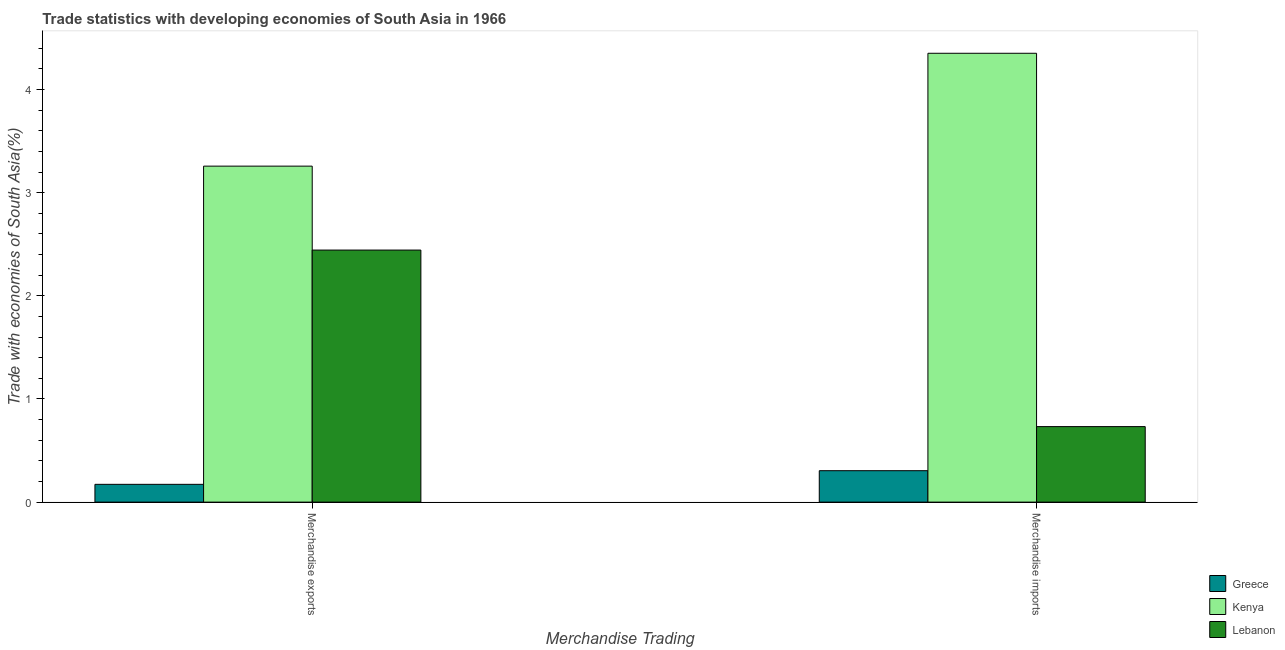How many groups of bars are there?
Your answer should be compact. 2. Are the number of bars per tick equal to the number of legend labels?
Your response must be concise. Yes. How many bars are there on the 2nd tick from the left?
Your response must be concise. 3. How many bars are there on the 2nd tick from the right?
Your answer should be very brief. 3. What is the label of the 2nd group of bars from the left?
Ensure brevity in your answer.  Merchandise imports. What is the merchandise imports in Greece?
Your response must be concise. 0.3. Across all countries, what is the maximum merchandise exports?
Provide a short and direct response. 3.26. Across all countries, what is the minimum merchandise imports?
Ensure brevity in your answer.  0.3. In which country was the merchandise exports maximum?
Offer a very short reply. Kenya. What is the total merchandise exports in the graph?
Your response must be concise. 5.87. What is the difference between the merchandise imports in Kenya and that in Greece?
Your answer should be compact. 4.05. What is the difference between the merchandise imports in Kenya and the merchandise exports in Lebanon?
Give a very brief answer. 1.91. What is the average merchandise imports per country?
Offer a very short reply. 1.8. What is the difference between the merchandise imports and merchandise exports in Lebanon?
Your answer should be compact. -1.71. What is the ratio of the merchandise exports in Greece to that in Lebanon?
Ensure brevity in your answer.  0.07. In how many countries, is the merchandise exports greater than the average merchandise exports taken over all countries?
Your response must be concise. 2. What does the 2nd bar from the left in Merchandise exports represents?
Keep it short and to the point. Kenya. What does the 1st bar from the right in Merchandise exports represents?
Offer a terse response. Lebanon. How many bars are there?
Your answer should be compact. 6. What is the difference between two consecutive major ticks on the Y-axis?
Ensure brevity in your answer.  1. Are the values on the major ticks of Y-axis written in scientific E-notation?
Give a very brief answer. No. Does the graph contain any zero values?
Provide a succinct answer. No. Does the graph contain grids?
Give a very brief answer. No. How are the legend labels stacked?
Keep it short and to the point. Vertical. What is the title of the graph?
Keep it short and to the point. Trade statistics with developing economies of South Asia in 1966. Does "Somalia" appear as one of the legend labels in the graph?
Keep it short and to the point. No. What is the label or title of the X-axis?
Your response must be concise. Merchandise Trading. What is the label or title of the Y-axis?
Offer a very short reply. Trade with economies of South Asia(%). What is the Trade with economies of South Asia(%) in Greece in Merchandise exports?
Give a very brief answer. 0.17. What is the Trade with economies of South Asia(%) of Kenya in Merchandise exports?
Provide a short and direct response. 3.26. What is the Trade with economies of South Asia(%) in Lebanon in Merchandise exports?
Your answer should be very brief. 2.44. What is the Trade with economies of South Asia(%) of Greece in Merchandise imports?
Your answer should be compact. 0.3. What is the Trade with economies of South Asia(%) of Kenya in Merchandise imports?
Provide a succinct answer. 4.35. What is the Trade with economies of South Asia(%) of Lebanon in Merchandise imports?
Keep it short and to the point. 0.73. Across all Merchandise Trading, what is the maximum Trade with economies of South Asia(%) in Greece?
Offer a very short reply. 0.3. Across all Merchandise Trading, what is the maximum Trade with economies of South Asia(%) in Kenya?
Offer a very short reply. 4.35. Across all Merchandise Trading, what is the maximum Trade with economies of South Asia(%) of Lebanon?
Offer a terse response. 2.44. Across all Merchandise Trading, what is the minimum Trade with economies of South Asia(%) in Greece?
Provide a short and direct response. 0.17. Across all Merchandise Trading, what is the minimum Trade with economies of South Asia(%) in Kenya?
Offer a very short reply. 3.26. Across all Merchandise Trading, what is the minimum Trade with economies of South Asia(%) in Lebanon?
Provide a succinct answer. 0.73. What is the total Trade with economies of South Asia(%) of Greece in the graph?
Keep it short and to the point. 0.48. What is the total Trade with economies of South Asia(%) in Kenya in the graph?
Your response must be concise. 7.61. What is the total Trade with economies of South Asia(%) of Lebanon in the graph?
Provide a succinct answer. 3.18. What is the difference between the Trade with economies of South Asia(%) of Greece in Merchandise exports and that in Merchandise imports?
Ensure brevity in your answer.  -0.13. What is the difference between the Trade with economies of South Asia(%) of Kenya in Merchandise exports and that in Merchandise imports?
Your answer should be compact. -1.09. What is the difference between the Trade with economies of South Asia(%) of Lebanon in Merchandise exports and that in Merchandise imports?
Keep it short and to the point. 1.71. What is the difference between the Trade with economies of South Asia(%) in Greece in Merchandise exports and the Trade with economies of South Asia(%) in Kenya in Merchandise imports?
Your answer should be compact. -4.18. What is the difference between the Trade with economies of South Asia(%) in Greece in Merchandise exports and the Trade with economies of South Asia(%) in Lebanon in Merchandise imports?
Your response must be concise. -0.56. What is the difference between the Trade with economies of South Asia(%) of Kenya in Merchandise exports and the Trade with economies of South Asia(%) of Lebanon in Merchandise imports?
Offer a terse response. 2.53. What is the average Trade with economies of South Asia(%) of Greece per Merchandise Trading?
Provide a succinct answer. 0.24. What is the average Trade with economies of South Asia(%) of Kenya per Merchandise Trading?
Make the answer very short. 3.8. What is the average Trade with economies of South Asia(%) in Lebanon per Merchandise Trading?
Your answer should be compact. 1.59. What is the difference between the Trade with economies of South Asia(%) of Greece and Trade with economies of South Asia(%) of Kenya in Merchandise exports?
Provide a succinct answer. -3.09. What is the difference between the Trade with economies of South Asia(%) of Greece and Trade with economies of South Asia(%) of Lebanon in Merchandise exports?
Your response must be concise. -2.27. What is the difference between the Trade with economies of South Asia(%) in Kenya and Trade with economies of South Asia(%) in Lebanon in Merchandise exports?
Make the answer very short. 0.81. What is the difference between the Trade with economies of South Asia(%) in Greece and Trade with economies of South Asia(%) in Kenya in Merchandise imports?
Your answer should be very brief. -4.05. What is the difference between the Trade with economies of South Asia(%) of Greece and Trade with economies of South Asia(%) of Lebanon in Merchandise imports?
Offer a terse response. -0.43. What is the difference between the Trade with economies of South Asia(%) in Kenya and Trade with economies of South Asia(%) in Lebanon in Merchandise imports?
Your response must be concise. 3.62. What is the ratio of the Trade with economies of South Asia(%) in Greece in Merchandise exports to that in Merchandise imports?
Offer a very short reply. 0.57. What is the ratio of the Trade with economies of South Asia(%) of Kenya in Merchandise exports to that in Merchandise imports?
Offer a terse response. 0.75. What is the ratio of the Trade with economies of South Asia(%) in Lebanon in Merchandise exports to that in Merchandise imports?
Ensure brevity in your answer.  3.34. What is the difference between the highest and the second highest Trade with economies of South Asia(%) in Greece?
Your answer should be compact. 0.13. What is the difference between the highest and the second highest Trade with economies of South Asia(%) of Kenya?
Ensure brevity in your answer.  1.09. What is the difference between the highest and the second highest Trade with economies of South Asia(%) of Lebanon?
Provide a succinct answer. 1.71. What is the difference between the highest and the lowest Trade with economies of South Asia(%) of Greece?
Your answer should be very brief. 0.13. What is the difference between the highest and the lowest Trade with economies of South Asia(%) in Kenya?
Give a very brief answer. 1.09. What is the difference between the highest and the lowest Trade with economies of South Asia(%) in Lebanon?
Offer a terse response. 1.71. 